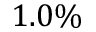Convert formula to latex. <formula><loc_0><loc_0><loc_500><loc_500>1 . 0 \%</formula> 